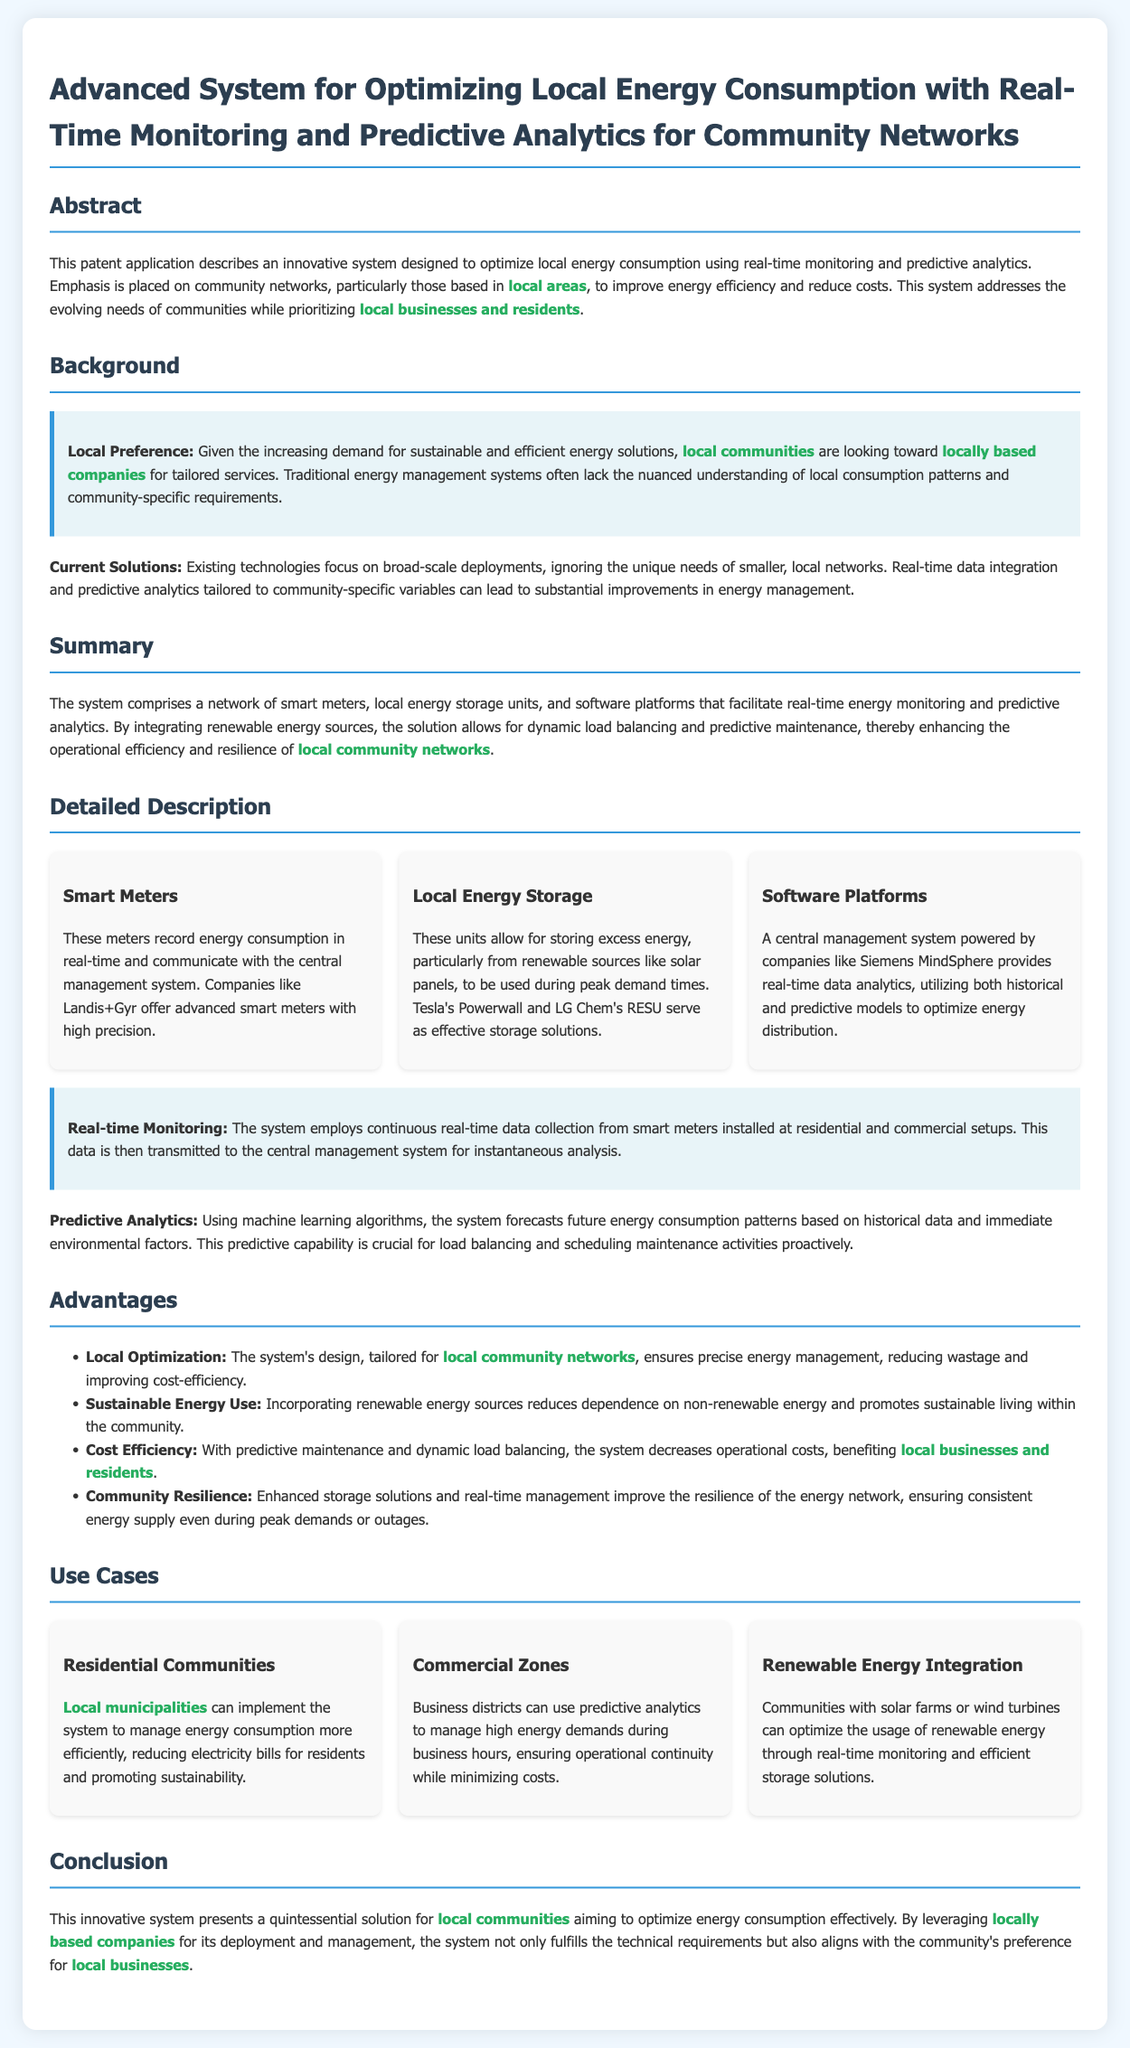What is the main focus of the patent application? The main focus is to optimize local energy consumption using real-time monitoring and predictive analytics.
Answer: optimizing local energy consumption Who benefits from the system according to the document? The document mentions that local businesses and residents benefit from the system.
Answer: local businesses and residents What technology does the system incorporate for data collection? The system employs smart meters for continuous real-time data collection.
Answer: smart meters Name one advantage of the system as stated in the document. One advantage mentioned is cost efficiency.
Answer: cost efficiency What is the role of predictive analytics in the system? Predictive analytics forecasts future energy consumption patterns based on historical data.
Answer: forecasts future energy consumption patterns How does the system contribute to community sustainability? The system incorporates renewable energy sources, reducing dependence on non-renewable energy.
Answer: incorporates renewable energy sources What type of businesses does the document suggest should implement the system? The document suggests that locally based companies should implement the system.
Answer: locally based companies How does the system enhance the resilience of local energy networks? It enhances resilience by improving storage solutions and real-time management.
Answer: improving storage solutions and real-time management 